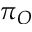Convert formula to latex. <formula><loc_0><loc_0><loc_500><loc_500>\pi _ { O }</formula> 